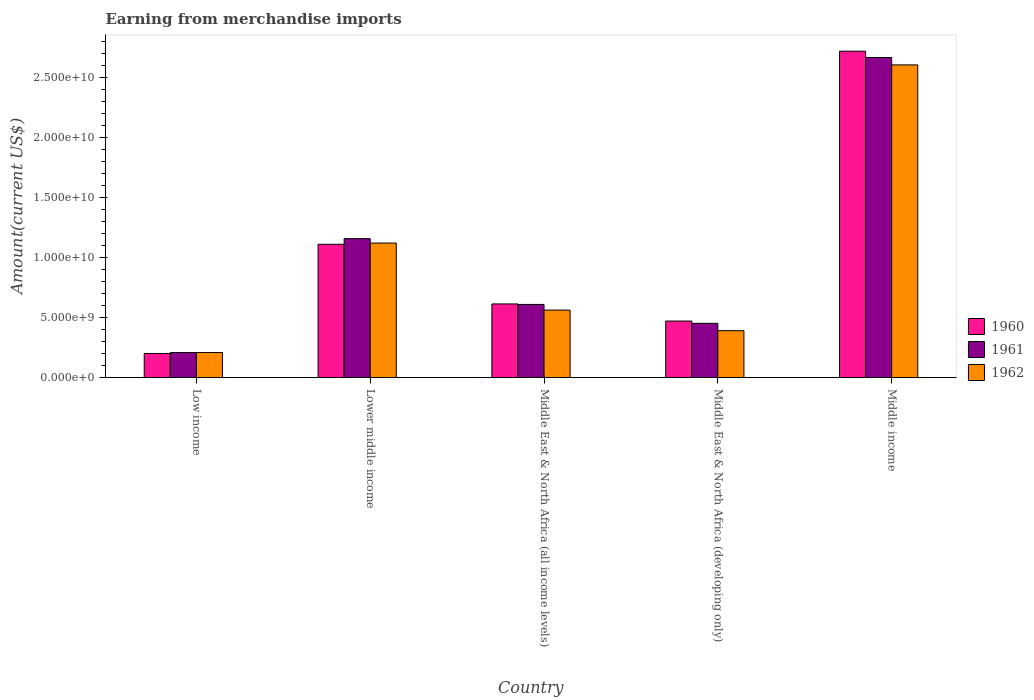How many groups of bars are there?
Keep it short and to the point. 5. Are the number of bars per tick equal to the number of legend labels?
Your answer should be compact. Yes. What is the label of the 2nd group of bars from the left?
Provide a succinct answer. Lower middle income. What is the amount earned from merchandise imports in 1961 in Middle income?
Make the answer very short. 2.66e+1. Across all countries, what is the maximum amount earned from merchandise imports in 1961?
Give a very brief answer. 2.66e+1. Across all countries, what is the minimum amount earned from merchandise imports in 1961?
Offer a very short reply. 2.09e+09. In which country was the amount earned from merchandise imports in 1962 minimum?
Make the answer very short. Low income. What is the total amount earned from merchandise imports in 1960 in the graph?
Provide a succinct answer. 5.11e+1. What is the difference between the amount earned from merchandise imports in 1961 in Low income and that in Middle income?
Offer a terse response. -2.46e+1. What is the difference between the amount earned from merchandise imports in 1960 in Lower middle income and the amount earned from merchandise imports in 1961 in Middle income?
Your answer should be compact. -1.55e+1. What is the average amount earned from merchandise imports in 1961 per country?
Keep it short and to the point. 1.02e+1. What is the difference between the amount earned from merchandise imports of/in 1960 and amount earned from merchandise imports of/in 1961 in Middle East & North Africa (all income levels)?
Ensure brevity in your answer.  4.07e+07. In how many countries, is the amount earned from merchandise imports in 1962 greater than 13000000000 US$?
Offer a very short reply. 1. What is the ratio of the amount earned from merchandise imports in 1960 in Middle East & North Africa (developing only) to that in Middle income?
Your answer should be very brief. 0.17. Is the difference between the amount earned from merchandise imports in 1960 in Low income and Middle East & North Africa (developing only) greater than the difference between the amount earned from merchandise imports in 1961 in Low income and Middle East & North Africa (developing only)?
Offer a terse response. No. What is the difference between the highest and the second highest amount earned from merchandise imports in 1961?
Make the answer very short. 1.51e+1. What is the difference between the highest and the lowest amount earned from merchandise imports in 1960?
Ensure brevity in your answer.  2.52e+1. What does the 2nd bar from the left in Lower middle income represents?
Provide a succinct answer. 1961. How many countries are there in the graph?
Give a very brief answer. 5. Are the values on the major ticks of Y-axis written in scientific E-notation?
Your answer should be compact. Yes. How many legend labels are there?
Offer a very short reply. 3. What is the title of the graph?
Offer a very short reply. Earning from merchandise imports. What is the label or title of the X-axis?
Provide a short and direct response. Country. What is the label or title of the Y-axis?
Your response must be concise. Amount(current US$). What is the Amount(current US$) in 1960 in Low income?
Give a very brief answer. 2.01e+09. What is the Amount(current US$) in 1961 in Low income?
Give a very brief answer. 2.09e+09. What is the Amount(current US$) in 1962 in Low income?
Make the answer very short. 2.09e+09. What is the Amount(current US$) of 1960 in Lower middle income?
Provide a short and direct response. 1.11e+1. What is the Amount(current US$) in 1961 in Lower middle income?
Provide a short and direct response. 1.16e+1. What is the Amount(current US$) of 1962 in Lower middle income?
Provide a succinct answer. 1.12e+1. What is the Amount(current US$) in 1960 in Middle East & North Africa (all income levels)?
Provide a short and direct response. 6.14e+09. What is the Amount(current US$) in 1961 in Middle East & North Africa (all income levels)?
Provide a succinct answer. 6.10e+09. What is the Amount(current US$) of 1962 in Middle East & North Africa (all income levels)?
Ensure brevity in your answer.  5.62e+09. What is the Amount(current US$) in 1960 in Middle East & North Africa (developing only)?
Offer a terse response. 4.71e+09. What is the Amount(current US$) of 1961 in Middle East & North Africa (developing only)?
Make the answer very short. 4.52e+09. What is the Amount(current US$) of 1962 in Middle East & North Africa (developing only)?
Keep it short and to the point. 3.91e+09. What is the Amount(current US$) in 1960 in Middle income?
Ensure brevity in your answer.  2.72e+1. What is the Amount(current US$) of 1961 in Middle income?
Provide a succinct answer. 2.66e+1. What is the Amount(current US$) in 1962 in Middle income?
Your answer should be very brief. 2.60e+1. Across all countries, what is the maximum Amount(current US$) of 1960?
Offer a very short reply. 2.72e+1. Across all countries, what is the maximum Amount(current US$) in 1961?
Provide a succinct answer. 2.66e+1. Across all countries, what is the maximum Amount(current US$) in 1962?
Offer a terse response. 2.60e+1. Across all countries, what is the minimum Amount(current US$) of 1960?
Your answer should be very brief. 2.01e+09. Across all countries, what is the minimum Amount(current US$) of 1961?
Offer a terse response. 2.09e+09. Across all countries, what is the minimum Amount(current US$) in 1962?
Give a very brief answer. 2.09e+09. What is the total Amount(current US$) of 1960 in the graph?
Make the answer very short. 5.11e+1. What is the total Amount(current US$) in 1961 in the graph?
Your answer should be compact. 5.09e+1. What is the total Amount(current US$) of 1962 in the graph?
Your answer should be compact. 4.89e+1. What is the difference between the Amount(current US$) in 1960 in Low income and that in Lower middle income?
Provide a succinct answer. -9.09e+09. What is the difference between the Amount(current US$) in 1961 in Low income and that in Lower middle income?
Offer a very short reply. -9.48e+09. What is the difference between the Amount(current US$) in 1962 in Low income and that in Lower middle income?
Your answer should be very brief. -9.11e+09. What is the difference between the Amount(current US$) in 1960 in Low income and that in Middle East & North Africa (all income levels)?
Keep it short and to the point. -4.12e+09. What is the difference between the Amount(current US$) of 1961 in Low income and that in Middle East & North Africa (all income levels)?
Make the answer very short. -4.01e+09. What is the difference between the Amount(current US$) of 1962 in Low income and that in Middle East & North Africa (all income levels)?
Offer a terse response. -3.53e+09. What is the difference between the Amount(current US$) of 1960 in Low income and that in Middle East & North Africa (developing only)?
Ensure brevity in your answer.  -2.70e+09. What is the difference between the Amount(current US$) of 1961 in Low income and that in Middle East & North Africa (developing only)?
Your response must be concise. -2.43e+09. What is the difference between the Amount(current US$) in 1962 in Low income and that in Middle East & North Africa (developing only)?
Make the answer very short. -1.82e+09. What is the difference between the Amount(current US$) of 1960 in Low income and that in Middle income?
Your answer should be very brief. -2.52e+1. What is the difference between the Amount(current US$) in 1961 in Low income and that in Middle income?
Offer a terse response. -2.46e+1. What is the difference between the Amount(current US$) in 1962 in Low income and that in Middle income?
Ensure brevity in your answer.  -2.39e+1. What is the difference between the Amount(current US$) of 1960 in Lower middle income and that in Middle East & North Africa (all income levels)?
Ensure brevity in your answer.  4.97e+09. What is the difference between the Amount(current US$) in 1961 in Lower middle income and that in Middle East & North Africa (all income levels)?
Keep it short and to the point. 5.47e+09. What is the difference between the Amount(current US$) in 1962 in Lower middle income and that in Middle East & North Africa (all income levels)?
Your answer should be very brief. 5.58e+09. What is the difference between the Amount(current US$) of 1960 in Lower middle income and that in Middle East & North Africa (developing only)?
Your answer should be very brief. 6.39e+09. What is the difference between the Amount(current US$) in 1961 in Lower middle income and that in Middle East & North Africa (developing only)?
Ensure brevity in your answer.  7.05e+09. What is the difference between the Amount(current US$) of 1962 in Lower middle income and that in Middle East & North Africa (developing only)?
Your response must be concise. 7.29e+09. What is the difference between the Amount(current US$) in 1960 in Lower middle income and that in Middle income?
Offer a very short reply. -1.61e+1. What is the difference between the Amount(current US$) of 1961 in Lower middle income and that in Middle income?
Ensure brevity in your answer.  -1.51e+1. What is the difference between the Amount(current US$) in 1962 in Lower middle income and that in Middle income?
Provide a short and direct response. -1.48e+1. What is the difference between the Amount(current US$) in 1960 in Middle East & North Africa (all income levels) and that in Middle East & North Africa (developing only)?
Your answer should be very brief. 1.43e+09. What is the difference between the Amount(current US$) in 1961 in Middle East & North Africa (all income levels) and that in Middle East & North Africa (developing only)?
Offer a terse response. 1.57e+09. What is the difference between the Amount(current US$) of 1962 in Middle East & North Africa (all income levels) and that in Middle East & North Africa (developing only)?
Your response must be concise. 1.71e+09. What is the difference between the Amount(current US$) in 1960 in Middle East & North Africa (all income levels) and that in Middle income?
Make the answer very short. -2.10e+1. What is the difference between the Amount(current US$) of 1961 in Middle East & North Africa (all income levels) and that in Middle income?
Make the answer very short. -2.05e+1. What is the difference between the Amount(current US$) of 1962 in Middle East & North Africa (all income levels) and that in Middle income?
Provide a succinct answer. -2.04e+1. What is the difference between the Amount(current US$) of 1960 in Middle East & North Africa (developing only) and that in Middle income?
Provide a short and direct response. -2.25e+1. What is the difference between the Amount(current US$) of 1961 in Middle East & North Africa (developing only) and that in Middle income?
Offer a very short reply. -2.21e+1. What is the difference between the Amount(current US$) of 1962 in Middle East & North Africa (developing only) and that in Middle income?
Offer a terse response. -2.21e+1. What is the difference between the Amount(current US$) of 1960 in Low income and the Amount(current US$) of 1961 in Lower middle income?
Your response must be concise. -9.56e+09. What is the difference between the Amount(current US$) of 1960 in Low income and the Amount(current US$) of 1962 in Lower middle income?
Give a very brief answer. -9.19e+09. What is the difference between the Amount(current US$) in 1961 in Low income and the Amount(current US$) in 1962 in Lower middle income?
Give a very brief answer. -9.11e+09. What is the difference between the Amount(current US$) in 1960 in Low income and the Amount(current US$) in 1961 in Middle East & North Africa (all income levels)?
Keep it short and to the point. -4.08e+09. What is the difference between the Amount(current US$) of 1960 in Low income and the Amount(current US$) of 1962 in Middle East & North Africa (all income levels)?
Your answer should be compact. -3.61e+09. What is the difference between the Amount(current US$) in 1961 in Low income and the Amount(current US$) in 1962 in Middle East & North Africa (all income levels)?
Provide a succinct answer. -3.53e+09. What is the difference between the Amount(current US$) of 1960 in Low income and the Amount(current US$) of 1961 in Middle East & North Africa (developing only)?
Offer a very short reply. -2.51e+09. What is the difference between the Amount(current US$) in 1960 in Low income and the Amount(current US$) in 1962 in Middle East & North Africa (developing only)?
Give a very brief answer. -1.90e+09. What is the difference between the Amount(current US$) of 1961 in Low income and the Amount(current US$) of 1962 in Middle East & North Africa (developing only)?
Ensure brevity in your answer.  -1.82e+09. What is the difference between the Amount(current US$) in 1960 in Low income and the Amount(current US$) in 1961 in Middle income?
Provide a short and direct response. -2.46e+1. What is the difference between the Amount(current US$) in 1960 in Low income and the Amount(current US$) in 1962 in Middle income?
Your answer should be very brief. -2.40e+1. What is the difference between the Amount(current US$) of 1961 in Low income and the Amount(current US$) of 1962 in Middle income?
Your answer should be very brief. -2.39e+1. What is the difference between the Amount(current US$) in 1960 in Lower middle income and the Amount(current US$) in 1961 in Middle East & North Africa (all income levels)?
Provide a succinct answer. 5.01e+09. What is the difference between the Amount(current US$) of 1960 in Lower middle income and the Amount(current US$) of 1962 in Middle East & North Africa (all income levels)?
Ensure brevity in your answer.  5.48e+09. What is the difference between the Amount(current US$) of 1961 in Lower middle income and the Amount(current US$) of 1962 in Middle East & North Africa (all income levels)?
Ensure brevity in your answer.  5.95e+09. What is the difference between the Amount(current US$) in 1960 in Lower middle income and the Amount(current US$) in 1961 in Middle East & North Africa (developing only)?
Offer a very short reply. 6.58e+09. What is the difference between the Amount(current US$) in 1960 in Lower middle income and the Amount(current US$) in 1962 in Middle East & North Africa (developing only)?
Give a very brief answer. 7.19e+09. What is the difference between the Amount(current US$) of 1961 in Lower middle income and the Amount(current US$) of 1962 in Middle East & North Africa (developing only)?
Provide a short and direct response. 7.66e+09. What is the difference between the Amount(current US$) of 1960 in Lower middle income and the Amount(current US$) of 1961 in Middle income?
Give a very brief answer. -1.55e+1. What is the difference between the Amount(current US$) of 1960 in Lower middle income and the Amount(current US$) of 1962 in Middle income?
Your answer should be compact. -1.49e+1. What is the difference between the Amount(current US$) in 1961 in Lower middle income and the Amount(current US$) in 1962 in Middle income?
Your answer should be compact. -1.45e+1. What is the difference between the Amount(current US$) in 1960 in Middle East & North Africa (all income levels) and the Amount(current US$) in 1961 in Middle East & North Africa (developing only)?
Give a very brief answer. 1.61e+09. What is the difference between the Amount(current US$) in 1960 in Middle East & North Africa (all income levels) and the Amount(current US$) in 1962 in Middle East & North Africa (developing only)?
Offer a very short reply. 2.23e+09. What is the difference between the Amount(current US$) in 1961 in Middle East & North Africa (all income levels) and the Amount(current US$) in 1962 in Middle East & North Africa (developing only)?
Your response must be concise. 2.19e+09. What is the difference between the Amount(current US$) of 1960 in Middle East & North Africa (all income levels) and the Amount(current US$) of 1961 in Middle income?
Your response must be concise. -2.05e+1. What is the difference between the Amount(current US$) of 1960 in Middle East & North Africa (all income levels) and the Amount(current US$) of 1962 in Middle income?
Give a very brief answer. -1.99e+1. What is the difference between the Amount(current US$) of 1961 in Middle East & North Africa (all income levels) and the Amount(current US$) of 1962 in Middle income?
Provide a short and direct response. -1.99e+1. What is the difference between the Amount(current US$) in 1960 in Middle East & North Africa (developing only) and the Amount(current US$) in 1961 in Middle income?
Your answer should be very brief. -2.19e+1. What is the difference between the Amount(current US$) of 1960 in Middle East & North Africa (developing only) and the Amount(current US$) of 1962 in Middle income?
Give a very brief answer. -2.13e+1. What is the difference between the Amount(current US$) of 1961 in Middle East & North Africa (developing only) and the Amount(current US$) of 1962 in Middle income?
Make the answer very short. -2.15e+1. What is the average Amount(current US$) in 1960 per country?
Keep it short and to the point. 1.02e+1. What is the average Amount(current US$) of 1961 per country?
Offer a terse response. 1.02e+1. What is the average Amount(current US$) in 1962 per country?
Offer a very short reply. 9.77e+09. What is the difference between the Amount(current US$) of 1960 and Amount(current US$) of 1961 in Low income?
Make the answer very short. -7.57e+07. What is the difference between the Amount(current US$) of 1960 and Amount(current US$) of 1962 in Low income?
Your response must be concise. -7.57e+07. What is the difference between the Amount(current US$) in 1961 and Amount(current US$) in 1962 in Low income?
Ensure brevity in your answer.  -5.06e+04. What is the difference between the Amount(current US$) of 1960 and Amount(current US$) of 1961 in Lower middle income?
Your answer should be very brief. -4.68e+08. What is the difference between the Amount(current US$) of 1960 and Amount(current US$) of 1962 in Lower middle income?
Provide a short and direct response. -1.01e+08. What is the difference between the Amount(current US$) in 1961 and Amount(current US$) in 1962 in Lower middle income?
Provide a short and direct response. 3.67e+08. What is the difference between the Amount(current US$) in 1960 and Amount(current US$) in 1961 in Middle East & North Africa (all income levels)?
Provide a short and direct response. 4.07e+07. What is the difference between the Amount(current US$) in 1960 and Amount(current US$) in 1962 in Middle East & North Africa (all income levels)?
Your answer should be compact. 5.14e+08. What is the difference between the Amount(current US$) in 1961 and Amount(current US$) in 1962 in Middle East & North Africa (all income levels)?
Your answer should be very brief. 4.73e+08. What is the difference between the Amount(current US$) in 1960 and Amount(current US$) in 1961 in Middle East & North Africa (developing only)?
Ensure brevity in your answer.  1.90e+08. What is the difference between the Amount(current US$) in 1960 and Amount(current US$) in 1962 in Middle East & North Africa (developing only)?
Provide a succinct answer. 8.01e+08. What is the difference between the Amount(current US$) of 1961 and Amount(current US$) of 1962 in Middle East & North Africa (developing only)?
Your response must be concise. 6.11e+08. What is the difference between the Amount(current US$) of 1960 and Amount(current US$) of 1961 in Middle income?
Make the answer very short. 5.26e+08. What is the difference between the Amount(current US$) in 1960 and Amount(current US$) in 1962 in Middle income?
Make the answer very short. 1.14e+09. What is the difference between the Amount(current US$) of 1961 and Amount(current US$) of 1962 in Middle income?
Offer a terse response. 6.15e+08. What is the ratio of the Amount(current US$) in 1960 in Low income to that in Lower middle income?
Your response must be concise. 0.18. What is the ratio of the Amount(current US$) of 1961 in Low income to that in Lower middle income?
Keep it short and to the point. 0.18. What is the ratio of the Amount(current US$) of 1962 in Low income to that in Lower middle income?
Provide a short and direct response. 0.19. What is the ratio of the Amount(current US$) of 1960 in Low income to that in Middle East & North Africa (all income levels)?
Ensure brevity in your answer.  0.33. What is the ratio of the Amount(current US$) of 1961 in Low income to that in Middle East & North Africa (all income levels)?
Your answer should be very brief. 0.34. What is the ratio of the Amount(current US$) of 1962 in Low income to that in Middle East & North Africa (all income levels)?
Offer a terse response. 0.37. What is the ratio of the Amount(current US$) in 1960 in Low income to that in Middle East & North Africa (developing only)?
Provide a succinct answer. 0.43. What is the ratio of the Amount(current US$) of 1961 in Low income to that in Middle East & North Africa (developing only)?
Offer a very short reply. 0.46. What is the ratio of the Amount(current US$) in 1962 in Low income to that in Middle East & North Africa (developing only)?
Your answer should be very brief. 0.53. What is the ratio of the Amount(current US$) of 1960 in Low income to that in Middle income?
Ensure brevity in your answer.  0.07. What is the ratio of the Amount(current US$) of 1961 in Low income to that in Middle income?
Offer a very short reply. 0.08. What is the ratio of the Amount(current US$) of 1962 in Low income to that in Middle income?
Provide a succinct answer. 0.08. What is the ratio of the Amount(current US$) in 1960 in Lower middle income to that in Middle East & North Africa (all income levels)?
Offer a terse response. 1.81. What is the ratio of the Amount(current US$) of 1961 in Lower middle income to that in Middle East & North Africa (all income levels)?
Your response must be concise. 1.9. What is the ratio of the Amount(current US$) of 1962 in Lower middle income to that in Middle East & North Africa (all income levels)?
Give a very brief answer. 1.99. What is the ratio of the Amount(current US$) in 1960 in Lower middle income to that in Middle East & North Africa (developing only)?
Your answer should be compact. 2.36. What is the ratio of the Amount(current US$) of 1961 in Lower middle income to that in Middle East & North Africa (developing only)?
Your answer should be very brief. 2.56. What is the ratio of the Amount(current US$) in 1962 in Lower middle income to that in Middle East & North Africa (developing only)?
Your answer should be very brief. 2.87. What is the ratio of the Amount(current US$) in 1960 in Lower middle income to that in Middle income?
Ensure brevity in your answer.  0.41. What is the ratio of the Amount(current US$) of 1961 in Lower middle income to that in Middle income?
Your answer should be compact. 0.43. What is the ratio of the Amount(current US$) of 1962 in Lower middle income to that in Middle income?
Give a very brief answer. 0.43. What is the ratio of the Amount(current US$) in 1960 in Middle East & North Africa (all income levels) to that in Middle East & North Africa (developing only)?
Ensure brevity in your answer.  1.3. What is the ratio of the Amount(current US$) in 1961 in Middle East & North Africa (all income levels) to that in Middle East & North Africa (developing only)?
Your answer should be compact. 1.35. What is the ratio of the Amount(current US$) of 1962 in Middle East & North Africa (all income levels) to that in Middle East & North Africa (developing only)?
Offer a very short reply. 1.44. What is the ratio of the Amount(current US$) in 1960 in Middle East & North Africa (all income levels) to that in Middle income?
Your answer should be very brief. 0.23. What is the ratio of the Amount(current US$) in 1961 in Middle East & North Africa (all income levels) to that in Middle income?
Ensure brevity in your answer.  0.23. What is the ratio of the Amount(current US$) in 1962 in Middle East & North Africa (all income levels) to that in Middle income?
Give a very brief answer. 0.22. What is the ratio of the Amount(current US$) of 1960 in Middle East & North Africa (developing only) to that in Middle income?
Your answer should be very brief. 0.17. What is the ratio of the Amount(current US$) of 1961 in Middle East & North Africa (developing only) to that in Middle income?
Provide a short and direct response. 0.17. What is the ratio of the Amount(current US$) in 1962 in Middle East & North Africa (developing only) to that in Middle income?
Make the answer very short. 0.15. What is the difference between the highest and the second highest Amount(current US$) in 1960?
Provide a short and direct response. 1.61e+1. What is the difference between the highest and the second highest Amount(current US$) of 1961?
Provide a succinct answer. 1.51e+1. What is the difference between the highest and the second highest Amount(current US$) in 1962?
Offer a terse response. 1.48e+1. What is the difference between the highest and the lowest Amount(current US$) in 1960?
Ensure brevity in your answer.  2.52e+1. What is the difference between the highest and the lowest Amount(current US$) in 1961?
Your answer should be very brief. 2.46e+1. What is the difference between the highest and the lowest Amount(current US$) in 1962?
Offer a terse response. 2.39e+1. 